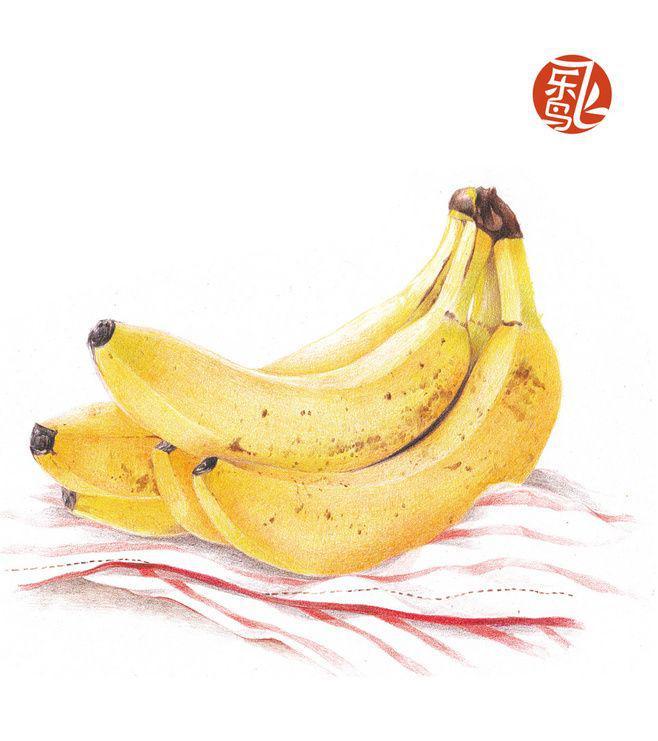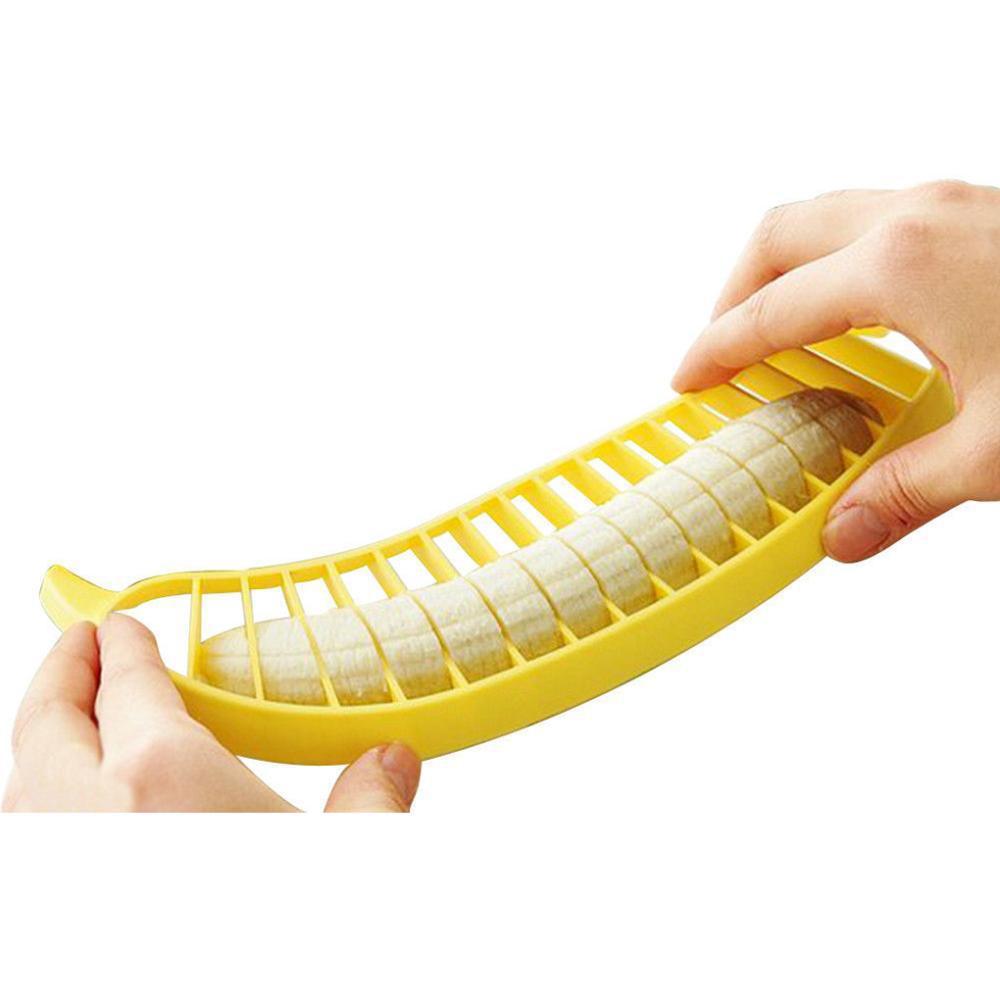The first image is the image on the left, the second image is the image on the right. Given the left and right images, does the statement "The left image contains a banana bunch with stems connected, and the right image includes at least part of an exposed, unpeeled banana." hold true? Answer yes or no. Yes. The first image is the image on the left, the second image is the image on the right. Assess this claim about the two images: "In one of the images, at least part of a banana has been cut into slices.". Correct or not? Answer yes or no. Yes. 